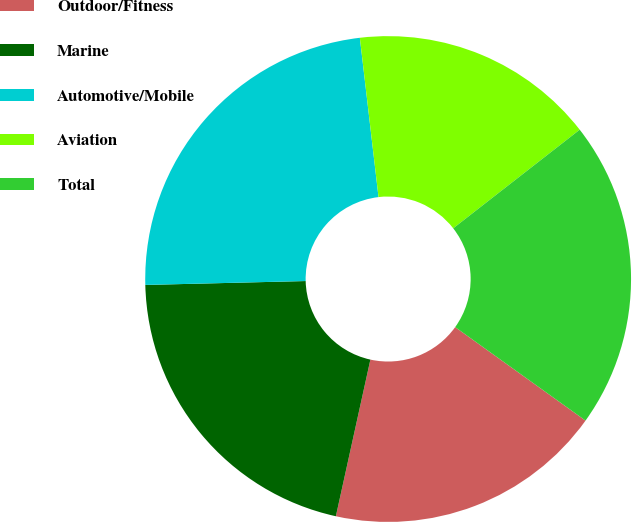<chart> <loc_0><loc_0><loc_500><loc_500><pie_chart><fcel>Outdoor/Fitness<fcel>Marine<fcel>Automotive/Mobile<fcel>Aviation<fcel>Total<nl><fcel>18.55%<fcel>21.16%<fcel>23.53%<fcel>16.32%<fcel>20.44%<nl></chart> 